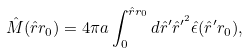Convert formula to latex. <formula><loc_0><loc_0><loc_500><loc_500>\hat { M } ( \hat { r } r _ { 0 } ) = 4 \pi a \int _ { 0 } ^ { \hat { r } r _ { 0 } } d \hat { r } ^ { \prime } \hat { r } ^ { \prime ^ { 2 } } \hat { \epsilon } ( \hat { r } ^ { \prime } r _ { 0 } ) ,</formula> 